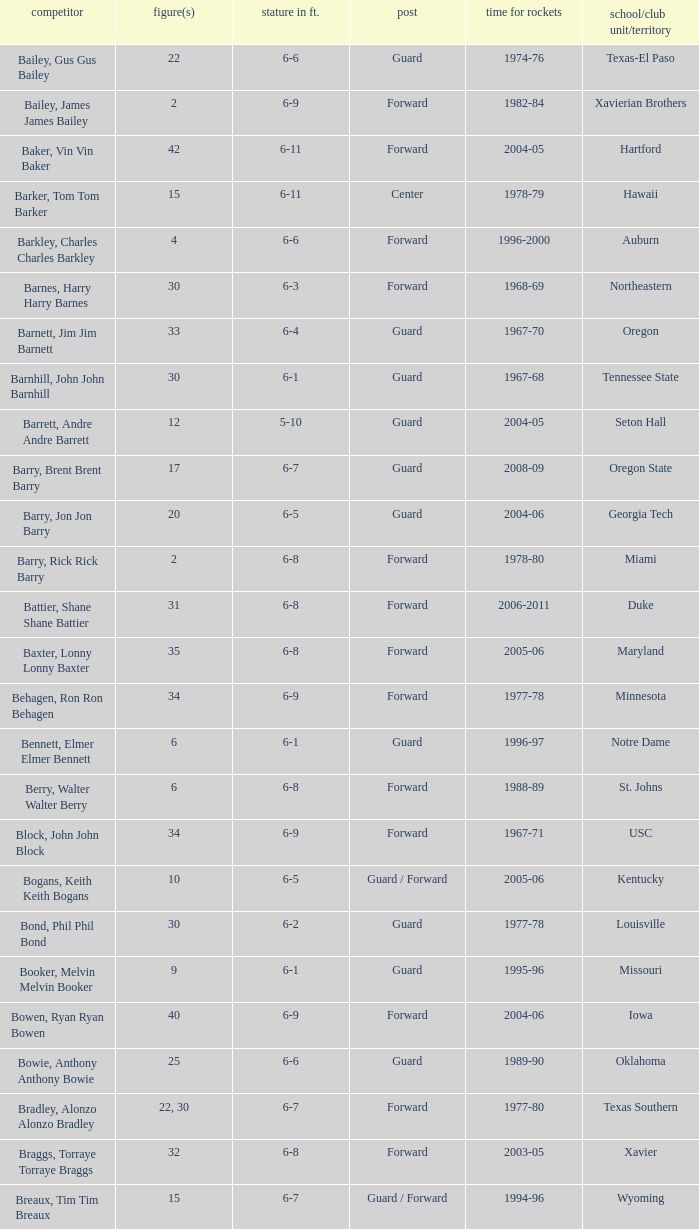What is the height of the player who attended Hartford? 6-11. 